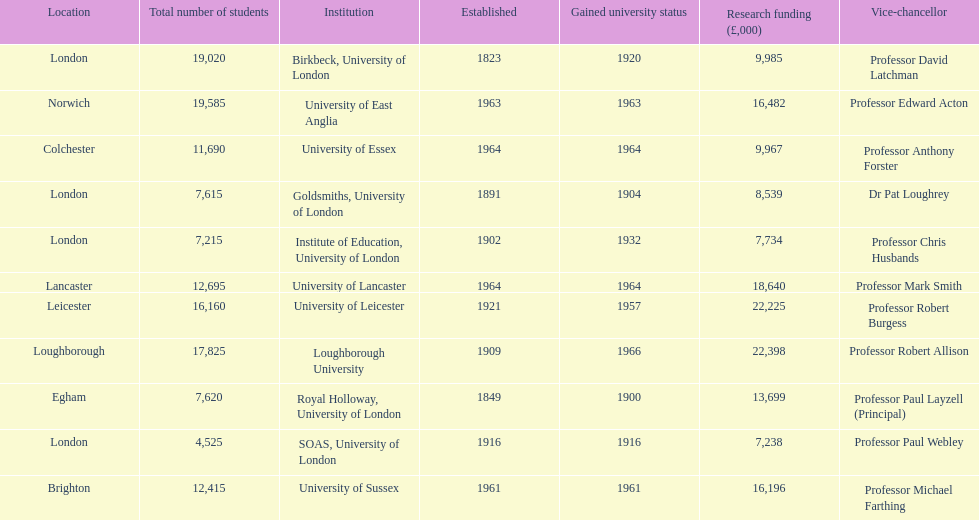Could you parse the entire table as a dict? {'header': ['Location', 'Total number of students', 'Institution', 'Established', 'Gained university status', 'Research funding (£,000)', 'Vice-chancellor'], 'rows': [['London', '19,020', 'Birkbeck, University of London', '1823', '1920', '9,985', 'Professor David Latchman'], ['Norwich', '19,585', 'University of East Anglia', '1963', '1963', '16,482', 'Professor Edward Acton'], ['Colchester', '11,690', 'University of Essex', '1964', '1964', '9,967', 'Professor Anthony Forster'], ['London', '7,615', 'Goldsmiths, University of London', '1891', '1904', '8,539', 'Dr Pat Loughrey'], ['London', '7,215', 'Institute of Education, University of London', '1902', '1932', '7,734', 'Professor Chris Husbands'], ['Lancaster', '12,695', 'University of Lancaster', '1964', '1964', '18,640', 'Professor Mark Smith'], ['Leicester', '16,160', 'University of Leicester', '1921', '1957', '22,225', 'Professor Robert Burgess'], ['Loughborough', '17,825', 'Loughborough University', '1909', '1966', '22,398', 'Professor Robert Allison'], ['Egham', '7,620', 'Royal Holloway, University of London', '1849', '1900', '13,699', 'Professor Paul Layzell (Principal)'], ['London', '4,525', 'SOAS, University of London', '1916', '1916', '7,238', 'Professor Paul Webley'], ['Brighton', '12,415', 'University of Sussex', '1961', '1961', '16,196', 'Professor Michael Farthing']]} Which institution has the most research funding? Loughborough University. 